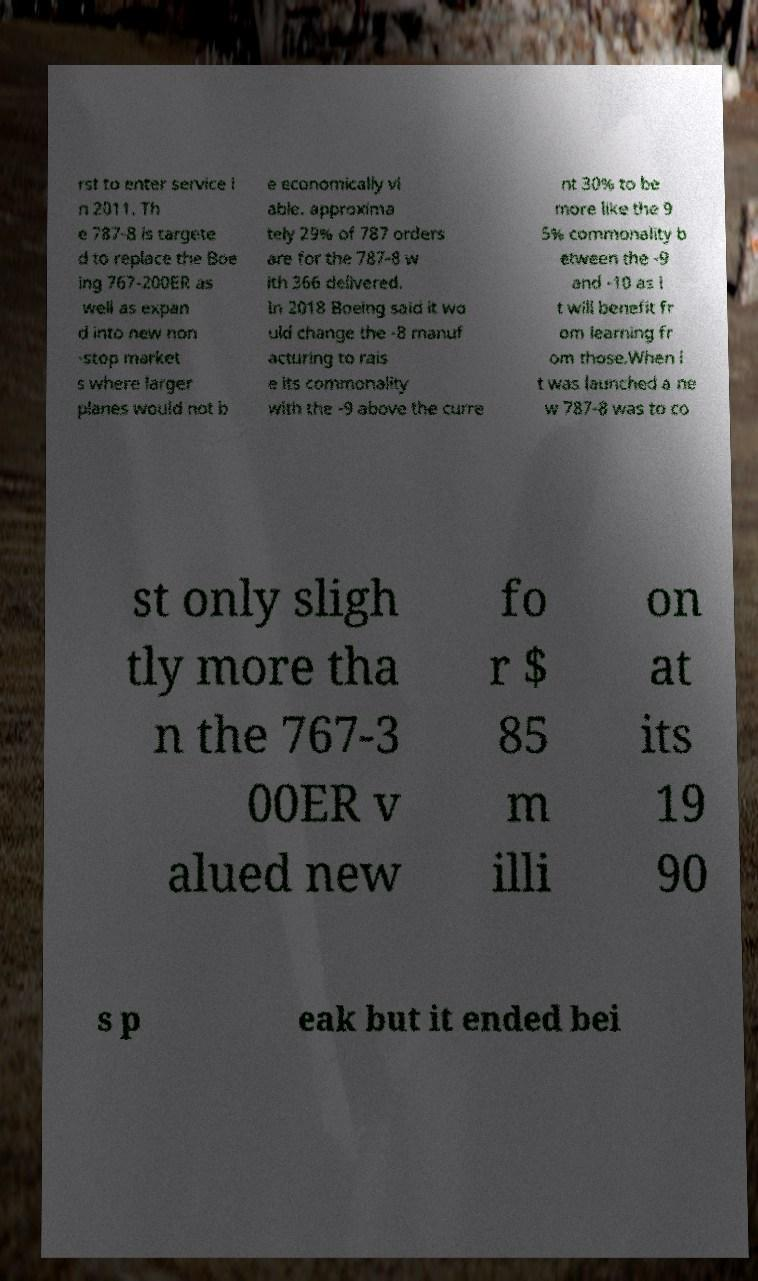Can you read and provide the text displayed in the image?This photo seems to have some interesting text. Can you extract and type it out for me? rst to enter service i n 2011. Th e 787-8 is targete d to replace the Boe ing 767-200ER as well as expan d into new non -stop market s where larger planes would not b e economically vi able. approxima tely 29% of 787 orders are for the 787-8 w ith 366 delivered. In 2018 Boeing said it wo uld change the -8 manuf acturing to rais e its commonality with the -9 above the curre nt 30% to be more like the 9 5% commonality b etween the -9 and -10 as i t will benefit fr om learning fr om those.When i t was launched a ne w 787-8 was to co st only sligh tly more tha n the 767-3 00ER v alued new fo r $ 85 m illi on at its 19 90 s p eak but it ended bei 